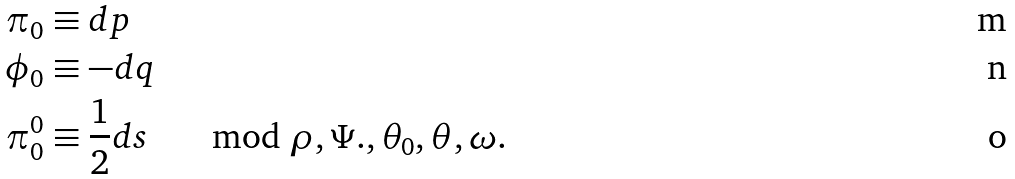Convert formula to latex. <formula><loc_0><loc_0><loc_500><loc_500>\pi _ { 0 } & \equiv d p \\ \phi _ { 0 } & \equiv - d q \\ \pi _ { 0 } ^ { 0 } & \equiv \frac { 1 } { 2 } d s \quad \mod \rho , \Psi . , \theta _ { 0 } , \theta , \omega .</formula> 